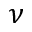<formula> <loc_0><loc_0><loc_500><loc_500>\nu</formula> 